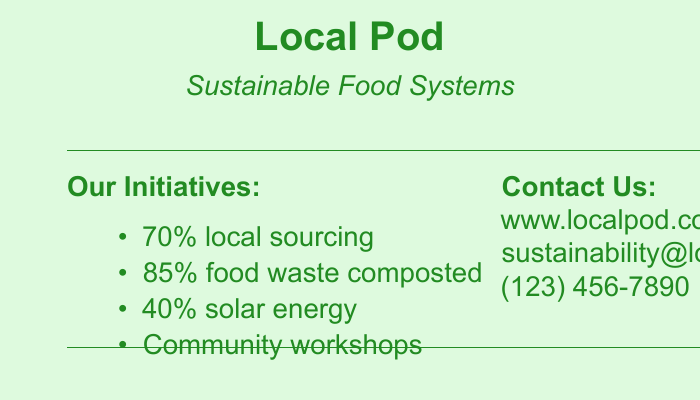what percentage of local sourcing is done? The document states that 70% of the sourcing is local, which is directly listed under the initiatives section.
Answer: 70% how much food waste is composted? According to the document, 85% of food waste is composted, which is specified in the initiatives section.
Answer: 85% what percentage of energy is solar? The document lists that 40% of the energy used is solar, found in the initiatives section.
Answer: 40% what is the website for Local Pod? The document provides the URL as www.localpod.com under the contact section.
Answer: www.localpod.com what type of workshops does Local Pod offer? The document mentions "Community workshops," indicating the type of workshops provided.
Answer: Community workshops how many contact methods are listed? The document provides three contact methods: website, email, and phone number, which can be counted.
Answer: 3 what is the primary focus of Local Pod? The document states the focus as "Empowering sustainable food systems through innovation and community engagement," which summarizes their mission.
Answer: Empowering sustainable food systems what color is used for the document background? The background color specified in the document is light green.
Answer: light green what is the main font used in the document? The document indicates that the main font is Arial, which is specified at the beginning of the code.
Answer: Arial 